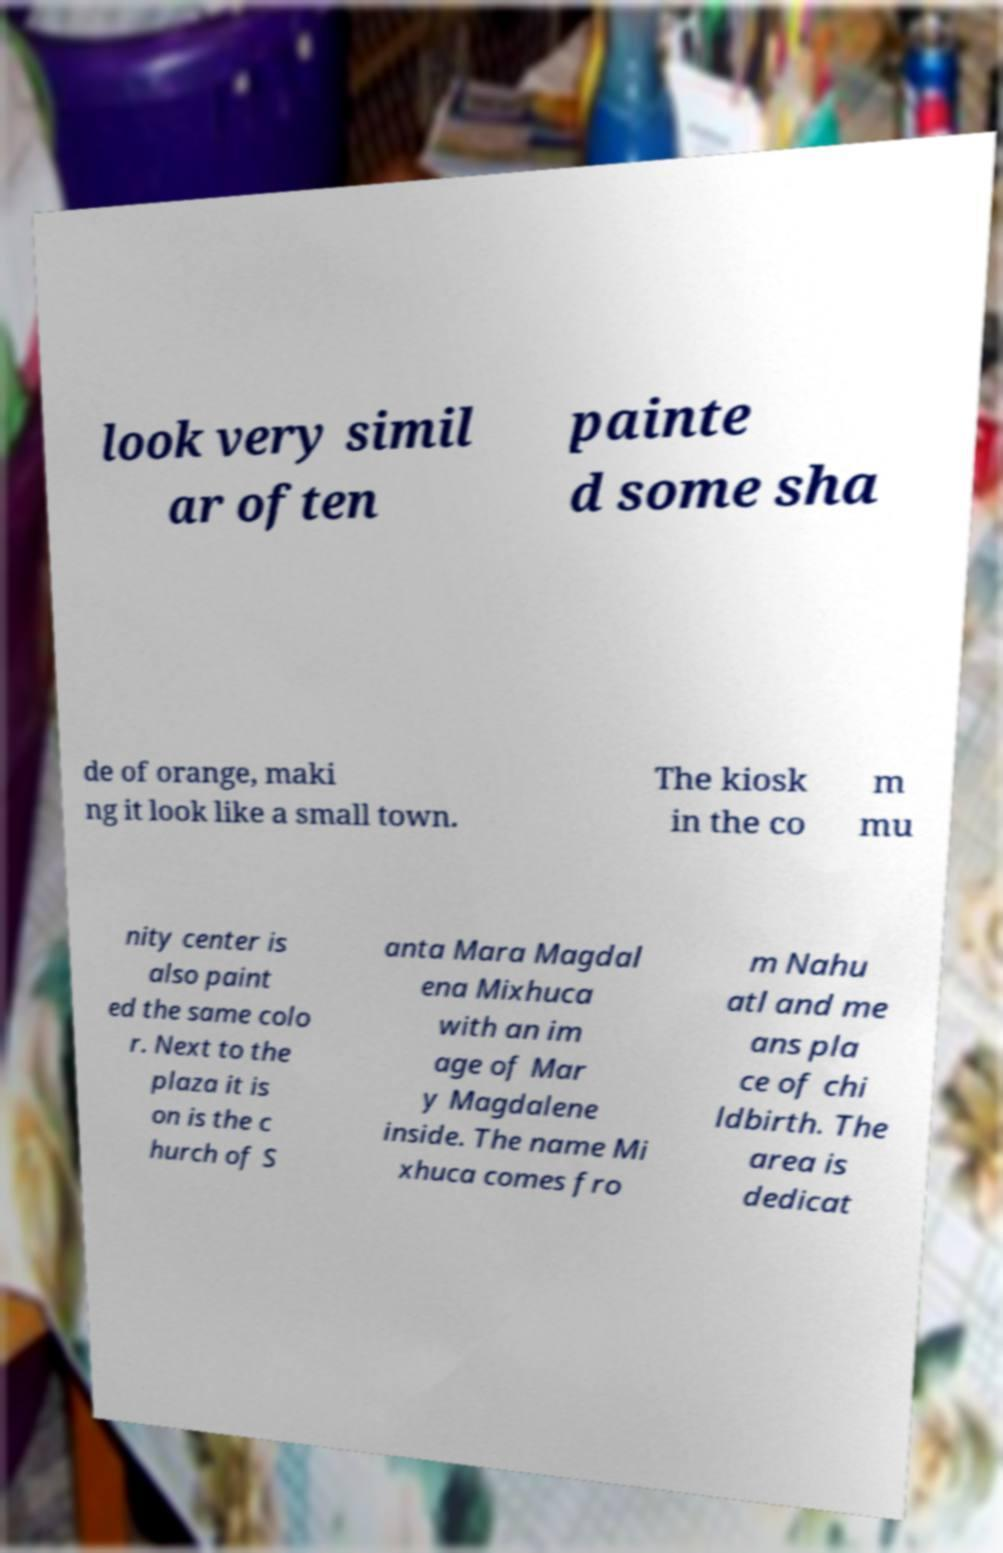Could you extract and type out the text from this image? look very simil ar often painte d some sha de of orange, maki ng it look like a small town. The kiosk in the co m mu nity center is also paint ed the same colo r. Next to the plaza it is on is the c hurch of S anta Mara Magdal ena Mixhuca with an im age of Mar y Magdalene inside. The name Mi xhuca comes fro m Nahu atl and me ans pla ce of chi ldbirth. The area is dedicat 